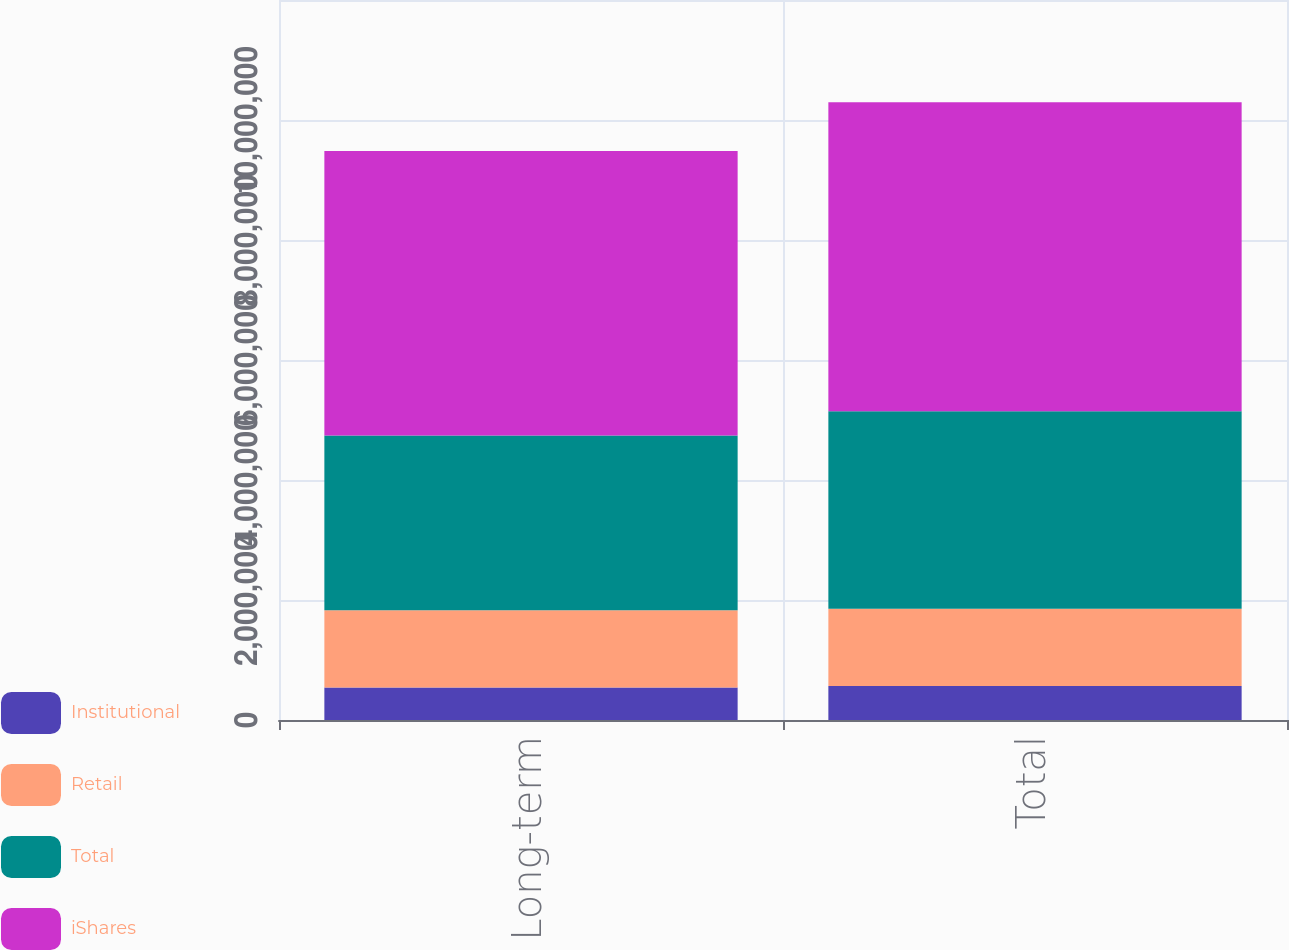Convert chart. <chart><loc_0><loc_0><loc_500><loc_500><stacked_bar_chart><ecel><fcel>Long-term<fcel>Total<nl><fcel>Institutional<fcel>541952<fcel>568174<nl><fcel>Retail<fcel>1.28788e+06<fcel>1.28788e+06<nl><fcel>Total<fcel>2.91166e+06<fcel>3.2918e+06<nl><fcel>iShares<fcel>4.74149e+06<fcel>5.14785e+06<nl></chart> 